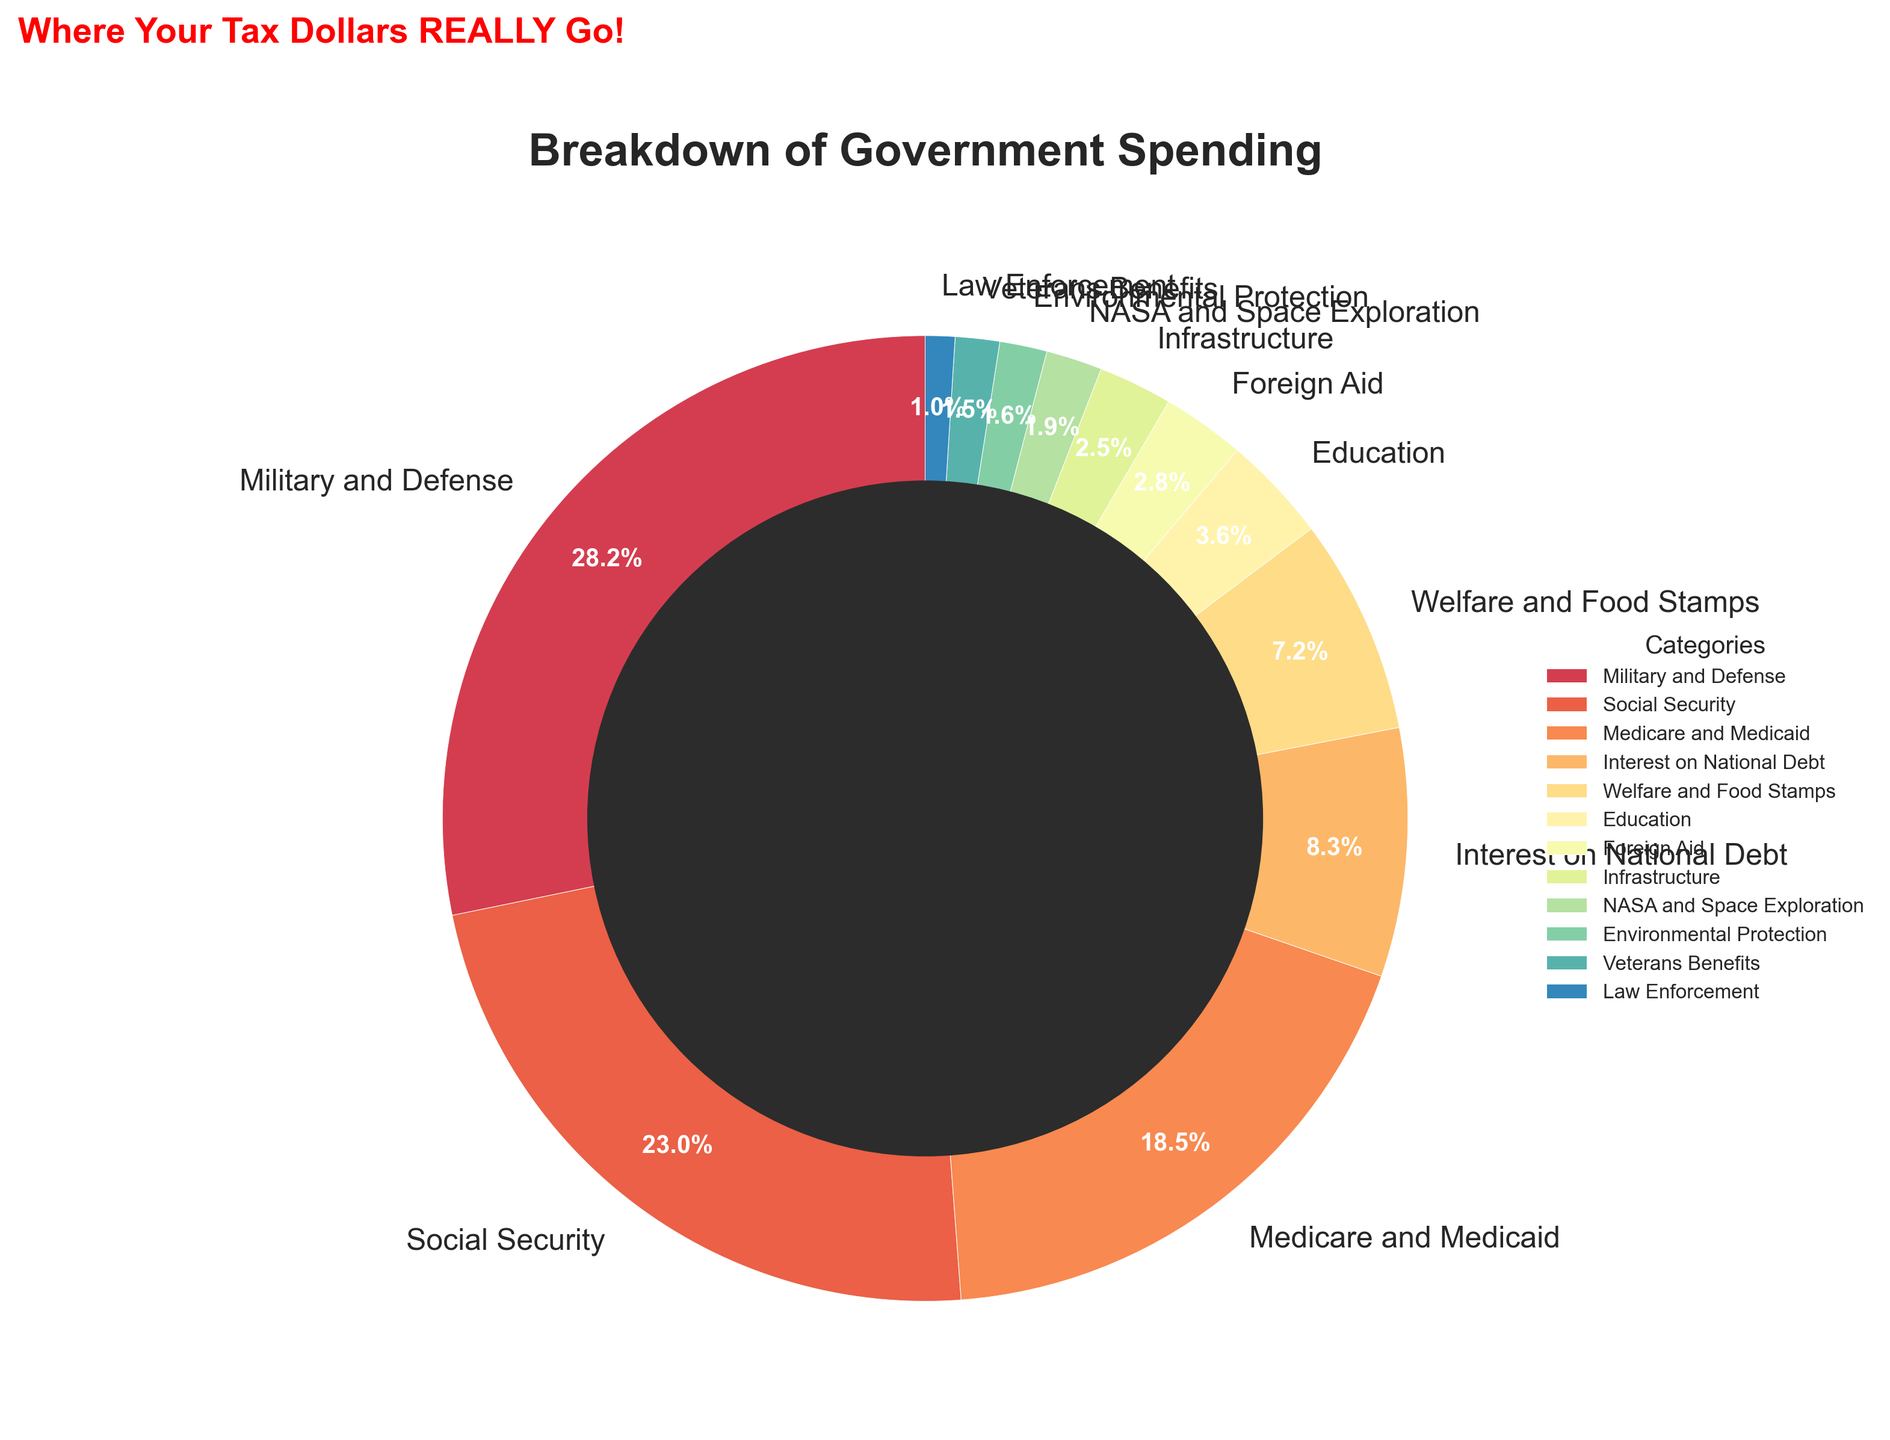Which category has the highest percentage of government spending? The segment with the largest size and the highest percentage label in the pie chart represents the category with the highest spending. This is "Military and Defense" with 28.5%.
Answer: Military and Defense Which category has a higher percentage of spending, Education or Foreign Aid? By comparing the two segments labeled "Education" and "Foreign Aid" on the pie chart, it's clear that "Education" has a higher percentage (3.6%) than "Foreign Aid" (2.8%).
Answer: Education What is the total percentage of government spending allocated to Social Security, Medicare and Medicaid, and Welfare and Food Stamps? Sum the percentages for "Social Security" (23.2%), "Medicare and Medicaid" (18.7%), and "Welfare and Food Stamps" (7.3%): 23.2 + 18.7 + 7.3 = 49.2%.
Answer: 49.2% How does the percentage of spending on Interest on National Debt compare to Veterans Benefits? Check the two segments labeled "Interest on National Debt" and "Veterans Benefits" on the pie chart. "Interest on National Debt" is 8.4% and "Veterans Benefits" is 1.5%, so the former is much larger.
Answer: Interest on National Debt Which categories combined account for more than 50% of the government spending? Sum the percentages from the largest categories until you exceed 50%. "Military and Defense" (28.5%), "Social Security" (23.2%) alone sum to 51.7%, already exceeding 50%.
Answer: Military and Defense, Social Security Which color is used to represent Military and Defense in the pie chart? Identify the color of the largest segment labeled "Military and Defense" in the pie chart. The corresponding color is the darkest one in the Spectral color map used.
Answer: Dark color from Spectral colormap What is the difference in percentage points between spending on Medicare and Medicaid and Welfare and Food Stamps? Subtract the percentage of "Welfare and Food Stamps" (7.3%) from "Medicare and Medicaid" (18.7%): 18.7 - 7.3 = 11.4%.
Answer: 11.4% Which category has the smallest percentage of government spending? The segment with the smallest size and the lowest percentage label in the pie chart represents the category with the smallest spending. This is "Law Enforcement" with 1%.
Answer: Law Enforcement If Veterans Benefits and Law Enforcement were combined into one category, what would be their total percentage? Sum the percentages for "Veterans Benefits" (1.5%) and "Law Enforcement" (1%): 1.5 + 1 = 2.5%.
Answer: 2.5% 